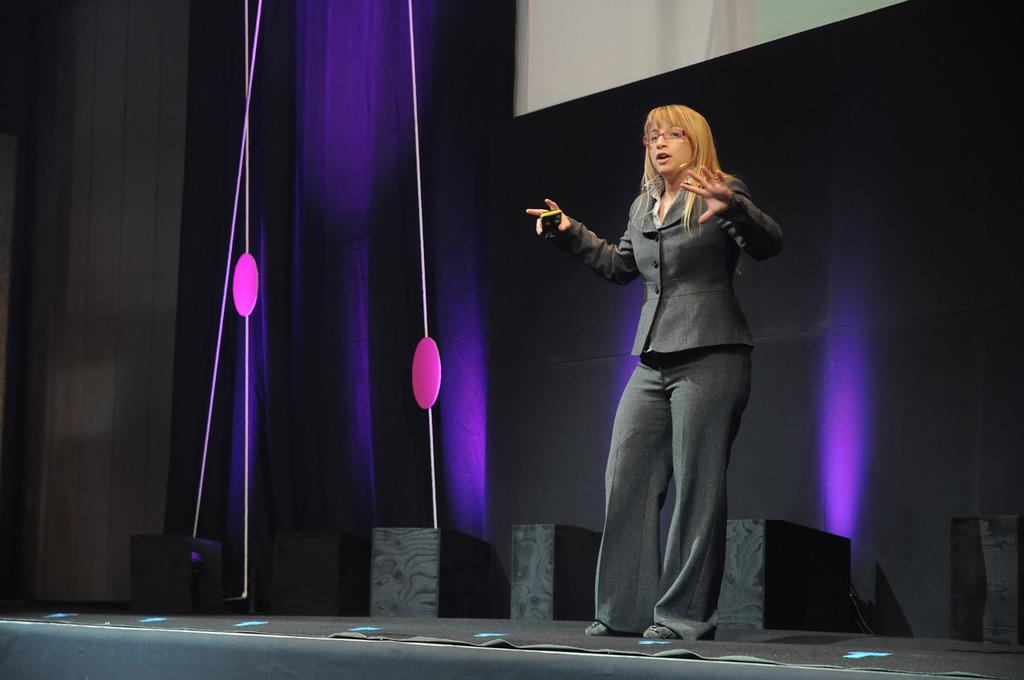Who is present in the image? There is a woman in the image. What is the woman doing in the image? The woman is standing in the image. What is the woman wearing in the image? The woman is wearing a suit in the image. Where is the woman located in the image? The woman is on a stage in the image. What type of lunchroom is visible in the background of the image? There is no lunchroom present in the image. Does the woman in the image express any regret? There is no indication of regret in the image, as it only shows a woman standing on a stage. 